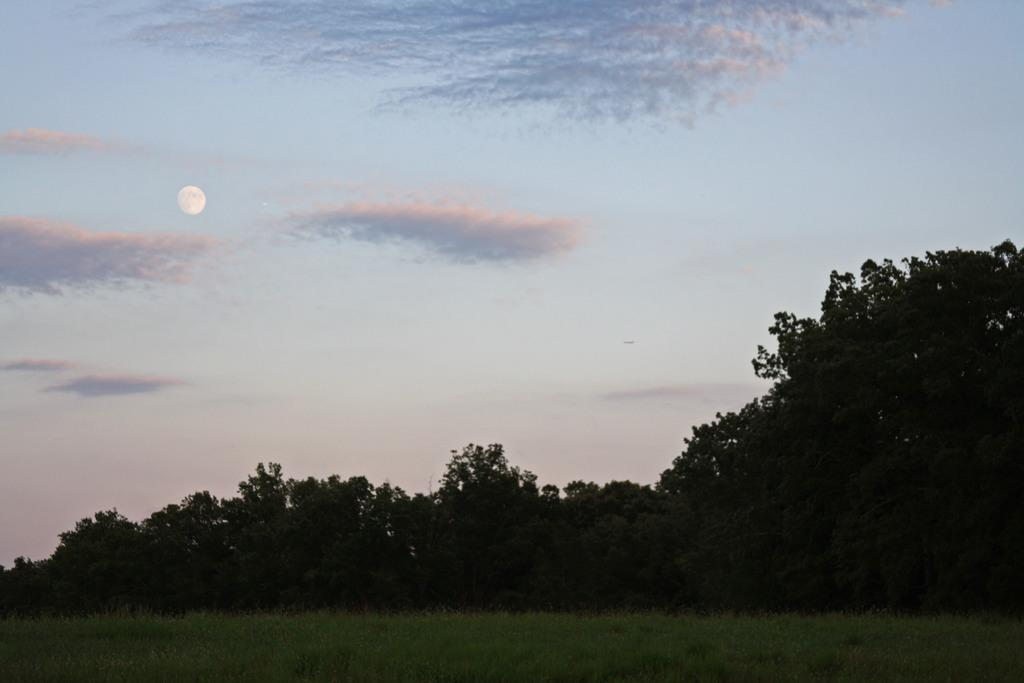What type of vegetation is present in the front of the image? There is grass in the front of the image. What can be seen in the center of the image? There are trees in the center of the image. How would you describe the sky in the image? The sky is cloudy in the image. What celestial body is visible in the sky? The moon is visible in the sky. How many jellyfish can be seen swimming in the grass in the image? There are no jellyfish present in the image; it features grass, trees, and a cloudy sky with the moon visible. What type of trip is being taken by the cloud in the image? There is no trip being taken by a cloud in the image; it simply depicts a cloudy sky. 